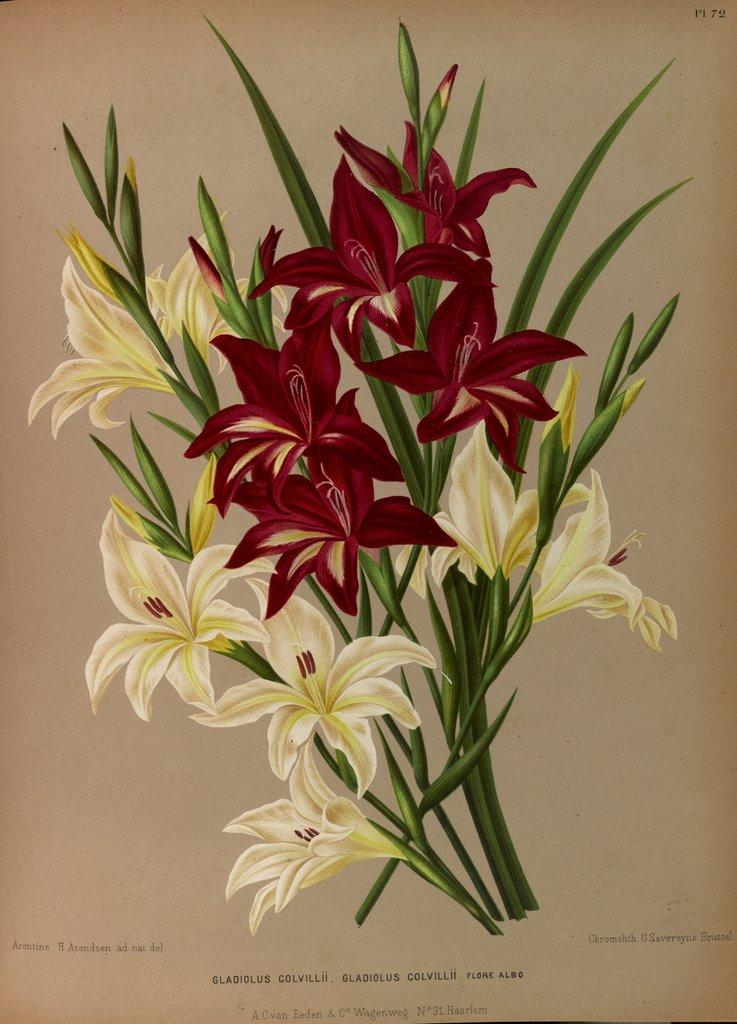What is depicted in the painting on the paper? There is a painting of flowers and leaves on a paper. What else is present on the paper besides the painting? There is text on the paper. What type of destruction is being caused by the passenger in the image? There is no passenger present in the image, and therefore no destruction can be observed. 